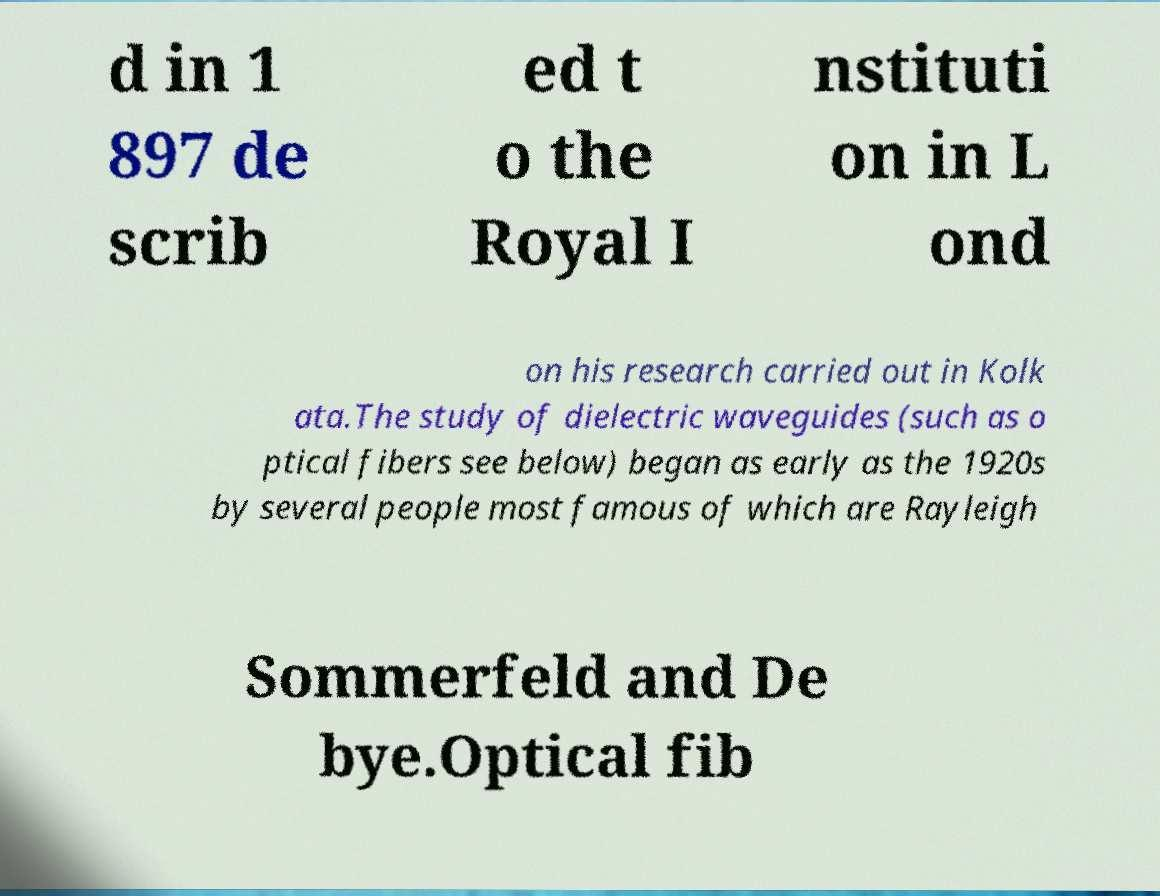Please read and relay the text visible in this image. What does it say? d in 1 897 de scrib ed t o the Royal I nstituti on in L ond on his research carried out in Kolk ata.The study of dielectric waveguides (such as o ptical fibers see below) began as early as the 1920s by several people most famous of which are Rayleigh Sommerfeld and De bye.Optical fib 